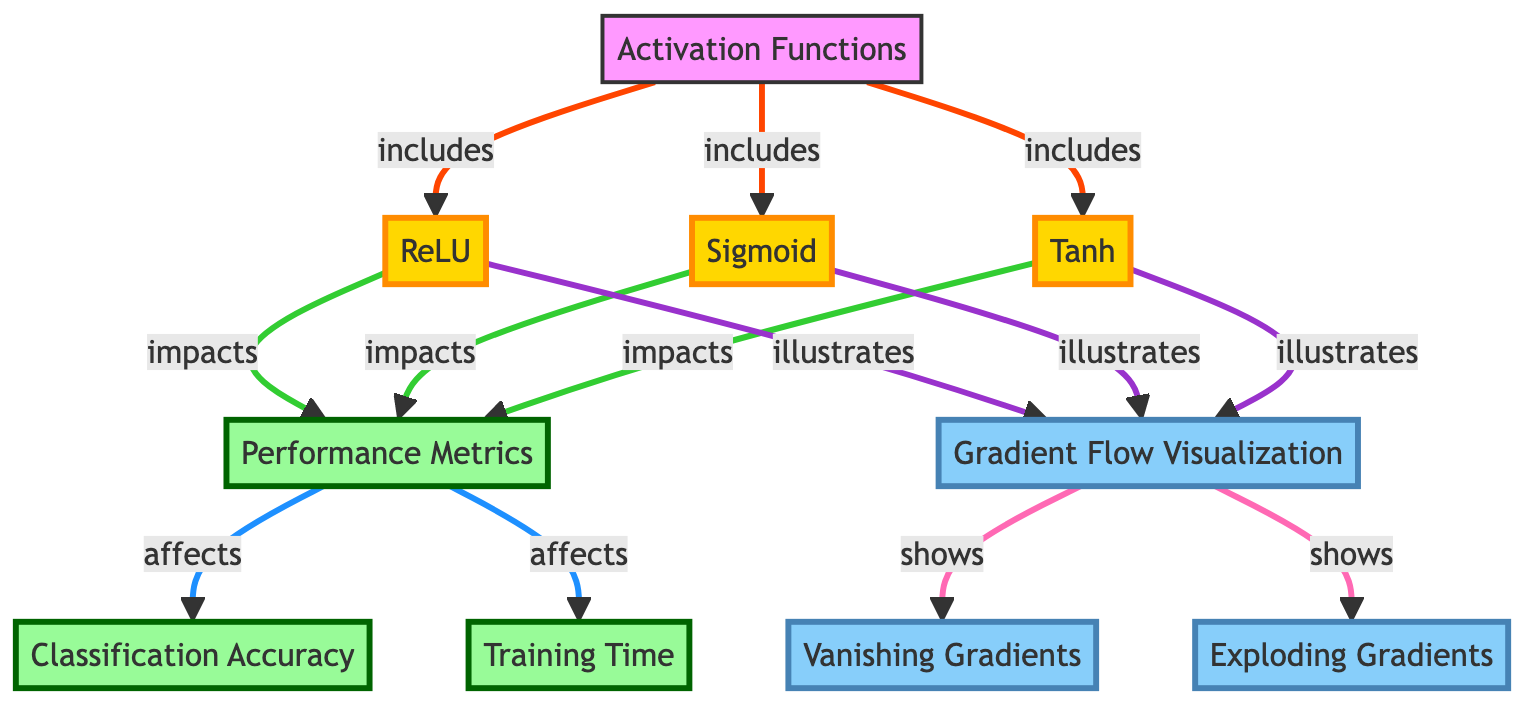What are the three activation functions included in the diagram? The diagram explicitly lists three activation functions: ReLU, Sigmoid, and Tanh. These are connected to the main node labeled "Activation Functions."
Answer: ReLU, Sigmoid, Tanh What does the ReLU activation function impact? According to the diagram, the ReLU activation function is connected to the performance metrics node, indicating that it has an impact on performance metrics.
Answer: Performance Metrics How many nodes represent performance metrics in the diagram? The diagram includes three nodes related to performance metrics: one for performance metrics itself and two for specific metrics: classification accuracy and training time. Thus, there are three nodes connected to performance metrics.
Answer: Three Which activation function illustrates gradient flow visualization? The diagram shows that all three activation functions (ReLU, Sigmoid, and Tanh) illustrate gradient flow visualization, as they each connect to the gradient flow visualization node.
Answer: ReLU, Sigmoid, Tanh What major issue is shown under gradient flow visualization? The diagram highlights two major issues under gradient flow visualization: vanishing gradients and exploding gradients. These are both connected to the node for gradient flow visualization.
Answer: Vanishing Gradients, Exploding Gradients Which performance metric directly affects training time? The diagram indicates that performance metrics affect training time as it illustrates a direct connection from performance metrics to the training time node.
Answer: Training Time Which activation function tends to cause vanishing gradients? The diagram suggests that the Sigmoid activation function is often associated with vanishing gradients due to its output range and the characteristics depicted in the gradient flow visualization.
Answer: Sigmoid How are the activation functions related to classification accuracy? The activation functions (ReLU, Sigmoid, Tanh) impact performance metrics, which in turn affects classification accuracy. This relationship is depicted through direct links in the diagram structure.
Answer: They impact performance metrics What type of diagram is this focused on? The diagram specifically focuses on machine learning, particularly comparing activation functions and their effects on network performance. It categorizes the relationships between the functions and performance metrics.
Answer: Machine Learning Diagram 